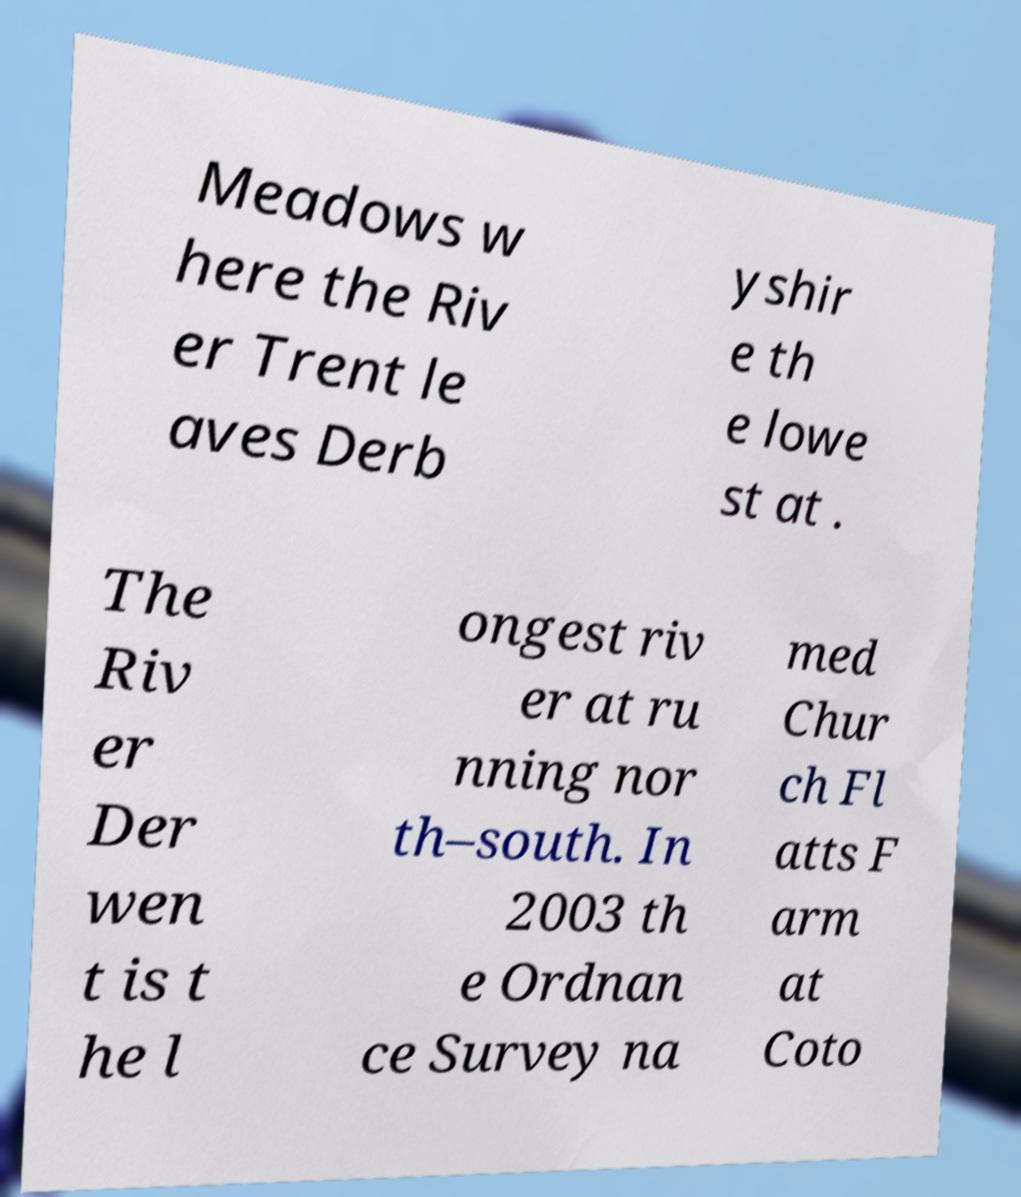Can you accurately transcribe the text from the provided image for me? Meadows w here the Riv er Trent le aves Derb yshir e th e lowe st at . The Riv er Der wen t is t he l ongest riv er at ru nning nor th–south. In 2003 th e Ordnan ce Survey na med Chur ch Fl atts F arm at Coto 